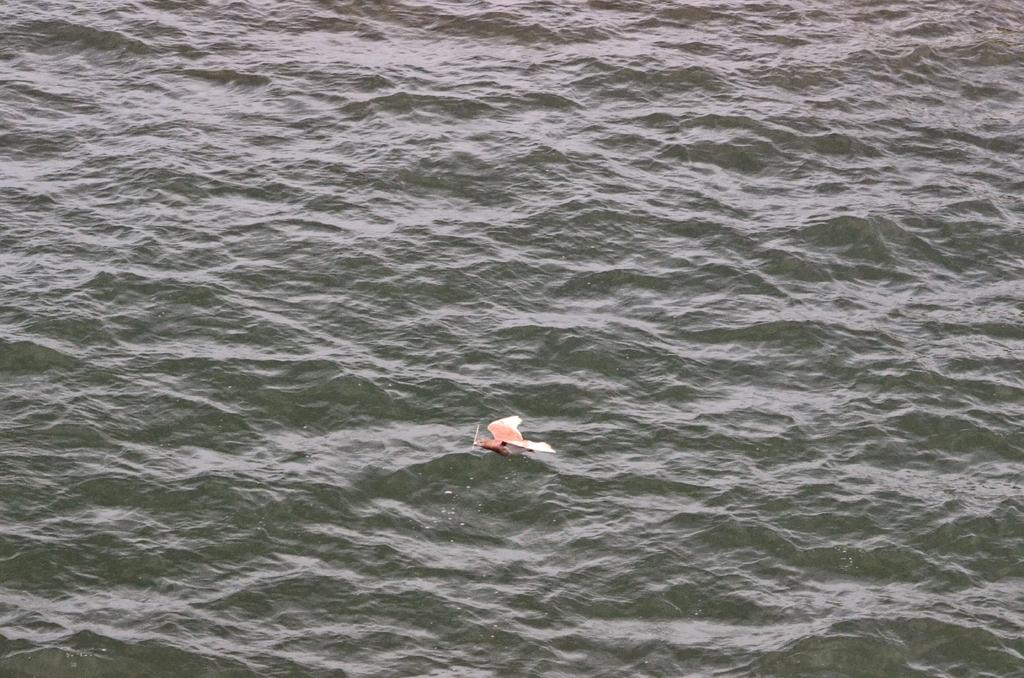What is the main subject of the image? There is a bird in the center of the image. Where is the bird located in the image? The bird is on the water. What type of lunchroom can be seen in the background of the image? There is no lunchroom present in the image; it features a bird on the water. How many trips did the bird take to reach its current location in the image? The image does not provide information about the bird's journey or the number of trips it took to reach its current location. 